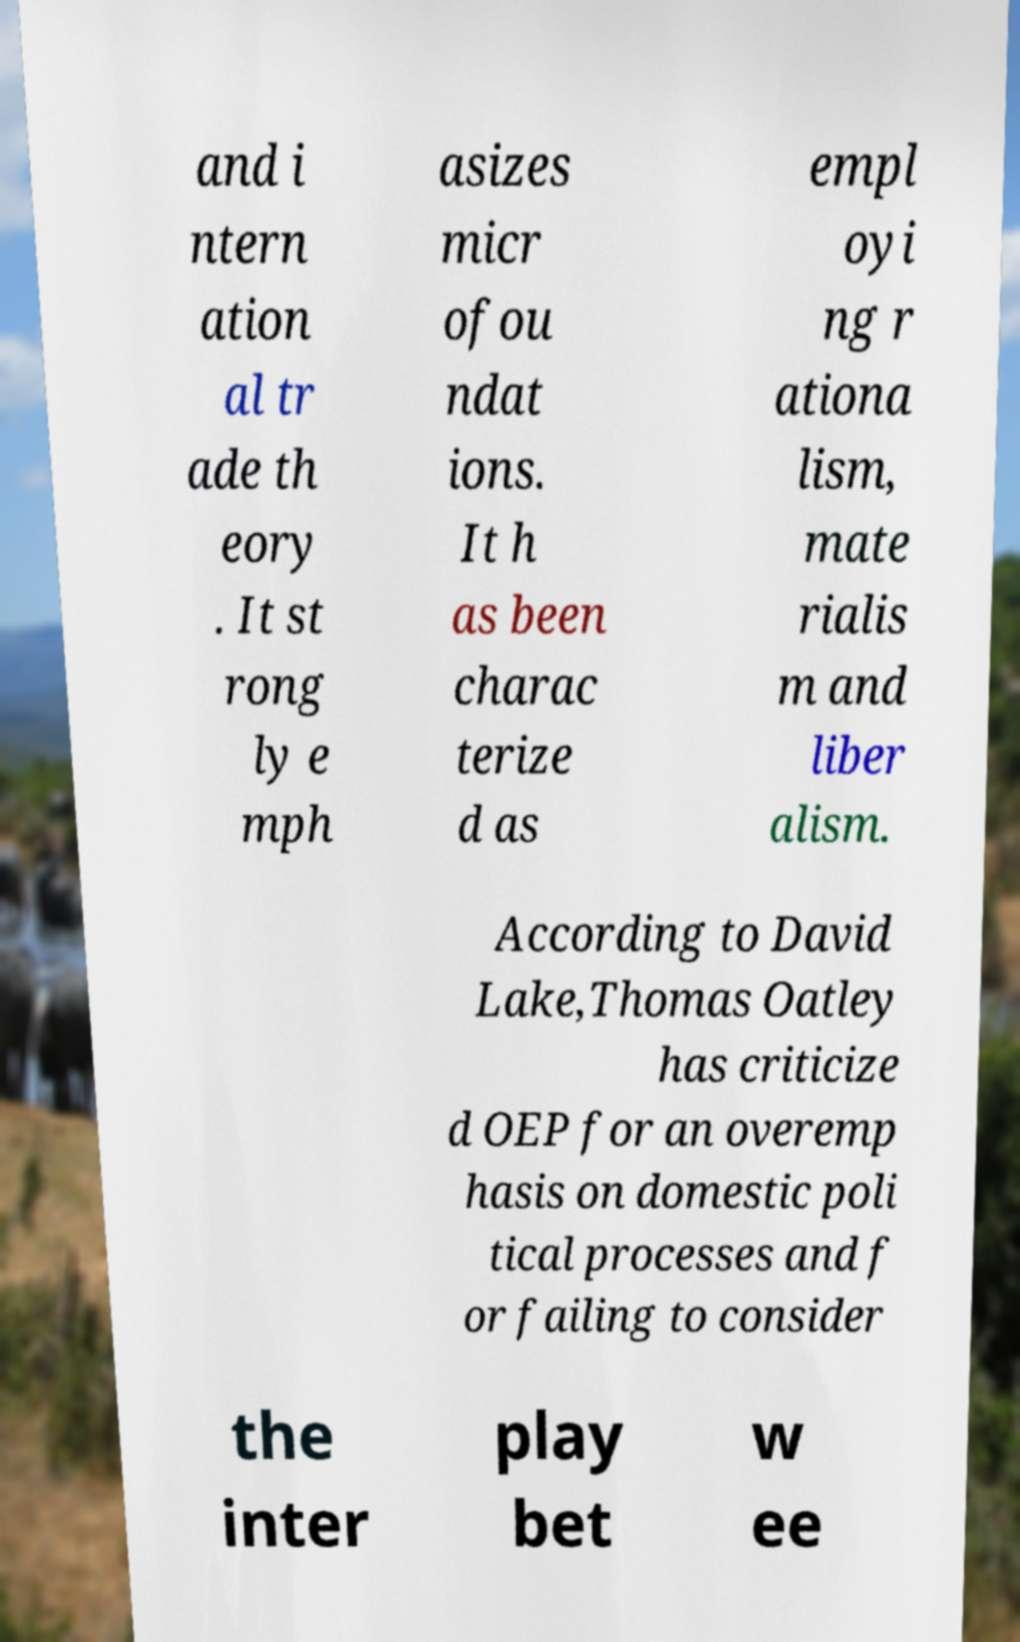Please read and relay the text visible in this image. What does it say? and i ntern ation al tr ade th eory . It st rong ly e mph asizes micr ofou ndat ions. It h as been charac terize d as empl oyi ng r ationa lism, mate rialis m and liber alism. According to David Lake,Thomas Oatley has criticize d OEP for an overemp hasis on domestic poli tical processes and f or failing to consider the inter play bet w ee 